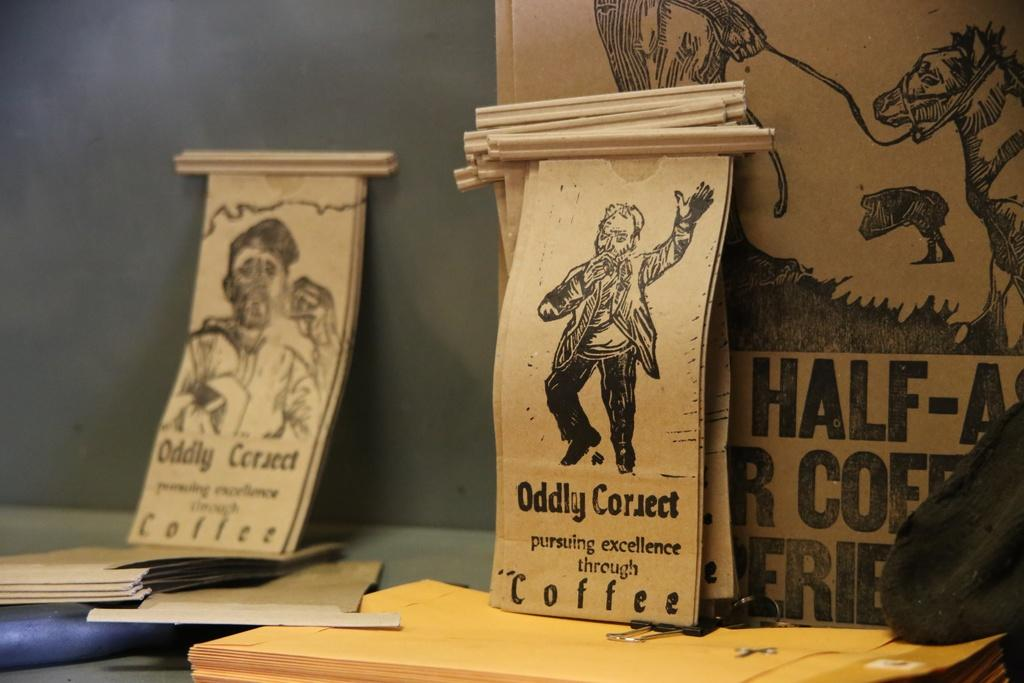<image>
Give a short and clear explanation of the subsequent image. Tan colored scrolls sit atop a table and one reads "Oddly Correct" pursuing excellence through Coffee. 